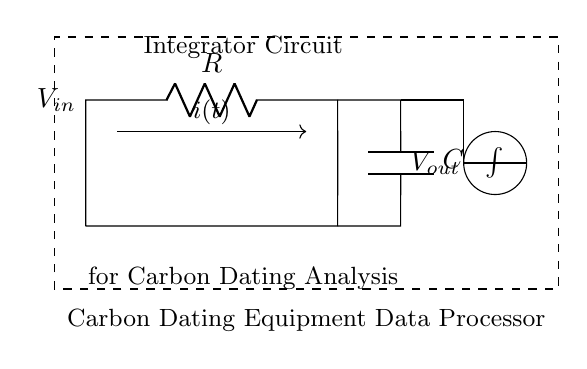What is the input voltage of the circuit? The input voltage, indicated by the label \( V_{in} \) on the left side of the circuit diagram, represents the voltage provided to the input of the integrator circuit.
Answer: V_in What type of circuit is represented? The circuit is labeled as an "Integrator Circuit," which indicates that it serves the purpose of integrating input signals over time.
Answer: Integrator Circuit What components are present in the circuit? The circuit comprises a resistor labeled \( R \) and a capacitor labeled \( C \), which are fundamental components of an integrator circuit.
Answer: Resistor and Capacitor What is the output of the circuit referred to as? The output voltage is denoted by \( V_{out} \) on the right side of the circuit, indicating the voltage output measured after the integration process.
Answer: V_out Explain the role of the resistor in this circuit. The resistor limits the current flowing into the capacitor, affecting the time constant of the circuit and thus the rate at which the capacitor charges or discharges. This influences the integration performed on the input voltage.
Answer: Limits current How does the output voltage relate to the input current over time? The output voltage \( V_{out} \) is proportional to the integral of the input current \( i(t) \) with respect to time, as indicated by the integral symbol shown in the diagram. This reflects how the circuit accumulates charge over time.
Answer: Integral of i(t) What does the dashed rectangle indicate in the circuit diagram? The dashed rectangle surrounding the components indicates that the components within are part of the "Carbon Dating Equipment Data Processor," suggesting that this integrator circuit is for processing data related to carbon dating.
Answer: Carbon Dating Equipment Data Processor 